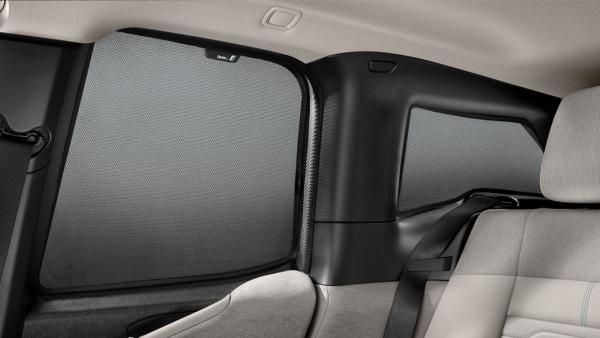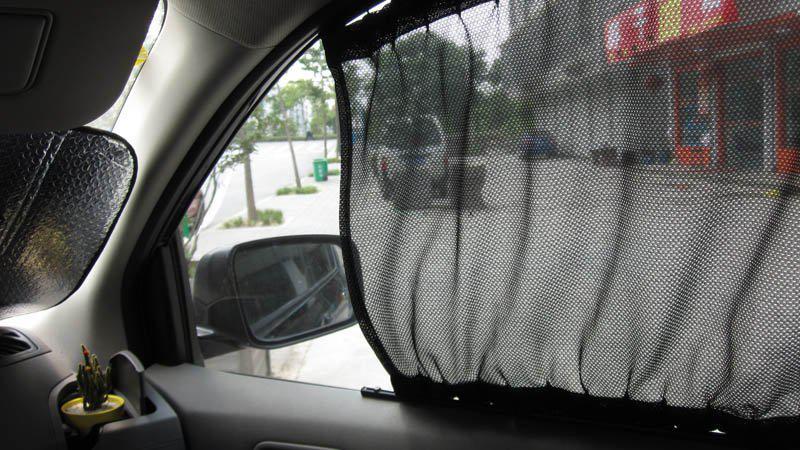The first image is the image on the left, the second image is the image on the right. For the images shown, is this caption "The car door is ajar in one of the images." true? Answer yes or no. No. 